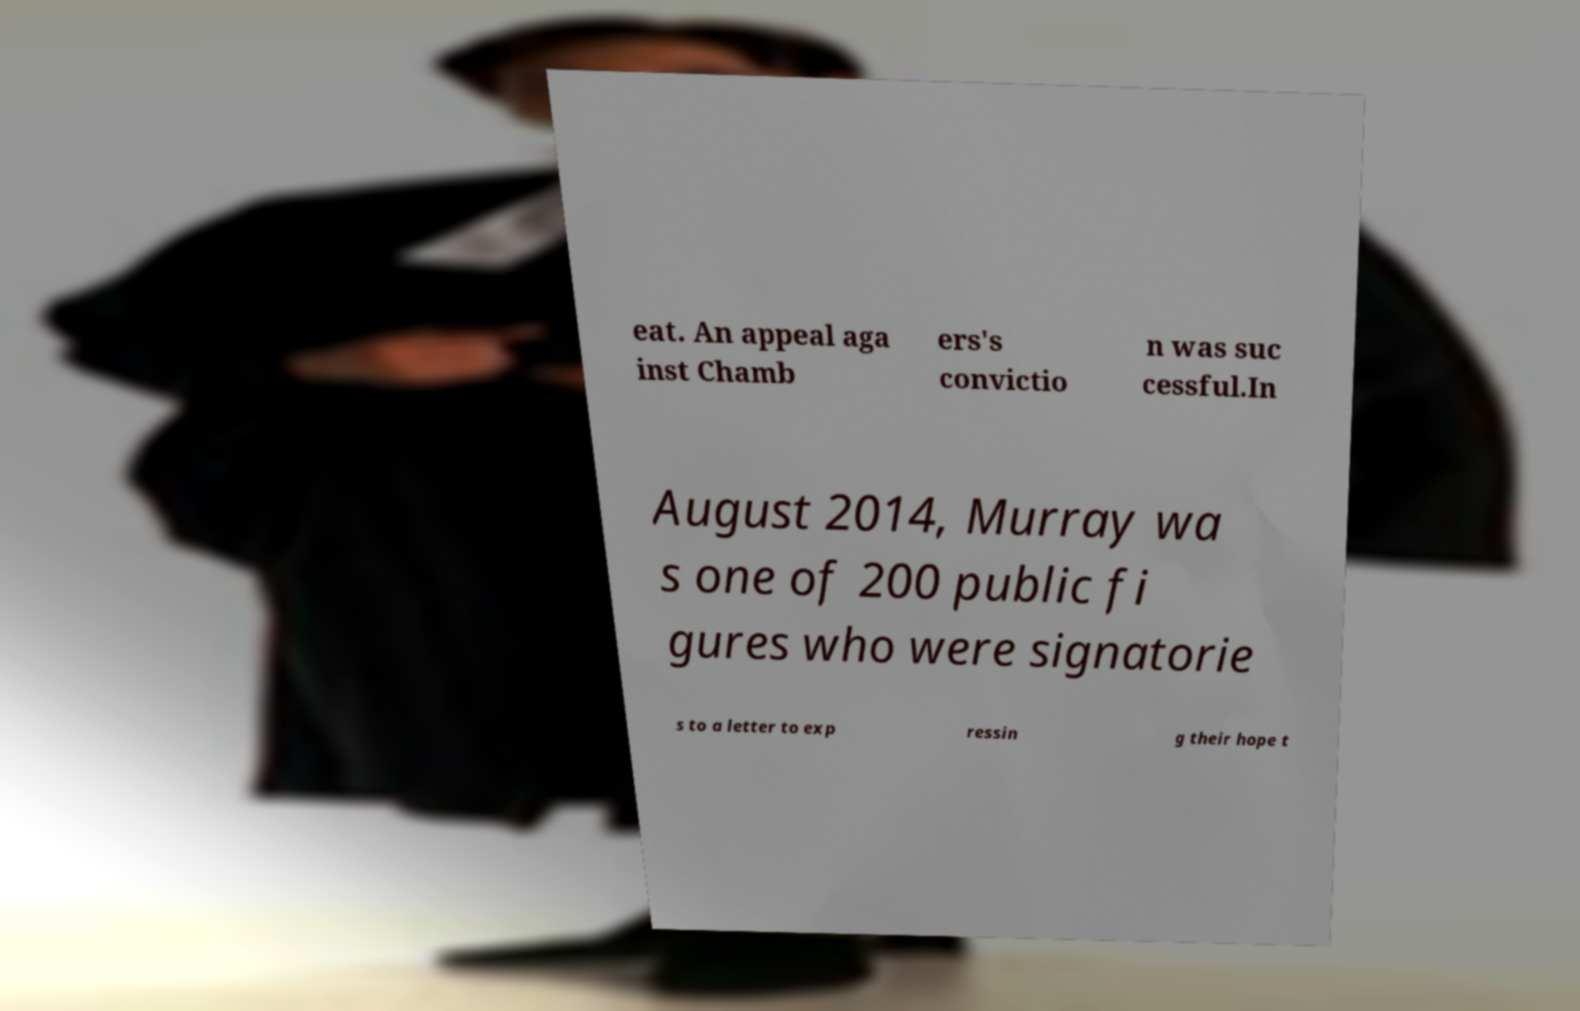There's text embedded in this image that I need extracted. Can you transcribe it verbatim? eat. An appeal aga inst Chamb ers's convictio n was suc cessful.In August 2014, Murray wa s one of 200 public fi gures who were signatorie s to a letter to exp ressin g their hope t 